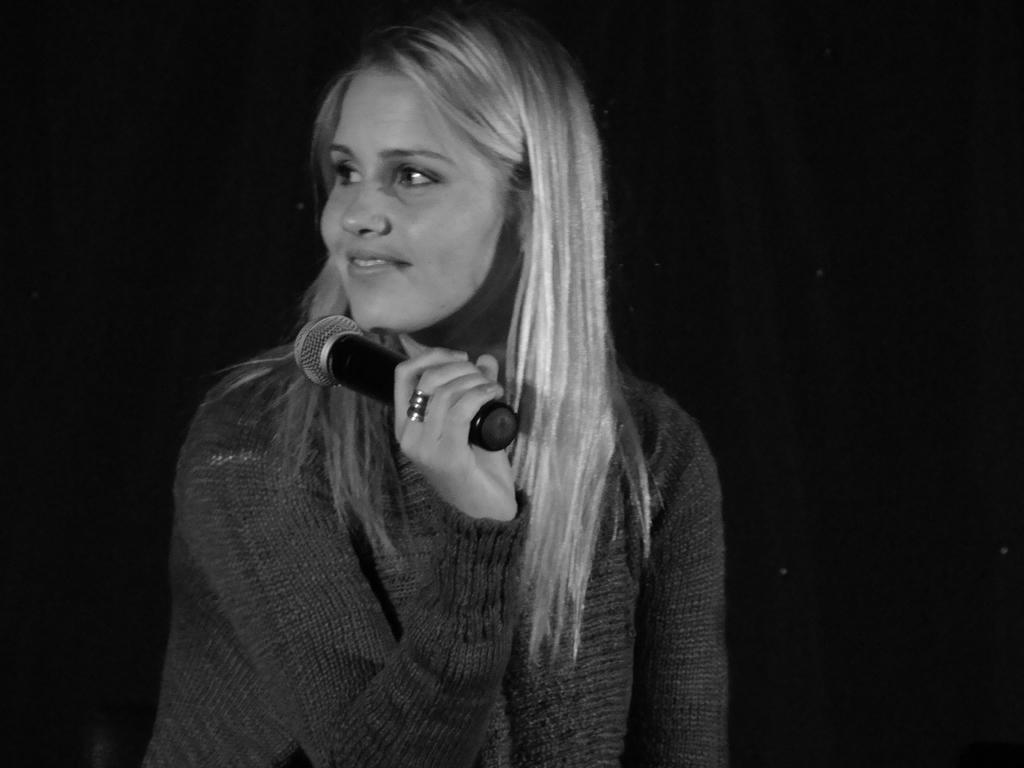What is the color scheme of the image? The image is black and white. Who is the main subject in the image? There is a girl in the image. What is the girl holding in the image? The girl is holding a mic. How many houses can be seen in the image? There are no houses visible in the image; it features a girl holding a mic. What type of sock is the girl wearing in the image? There is no sock visible in the image, as it is a black and white image and the girl's feet are not shown. 